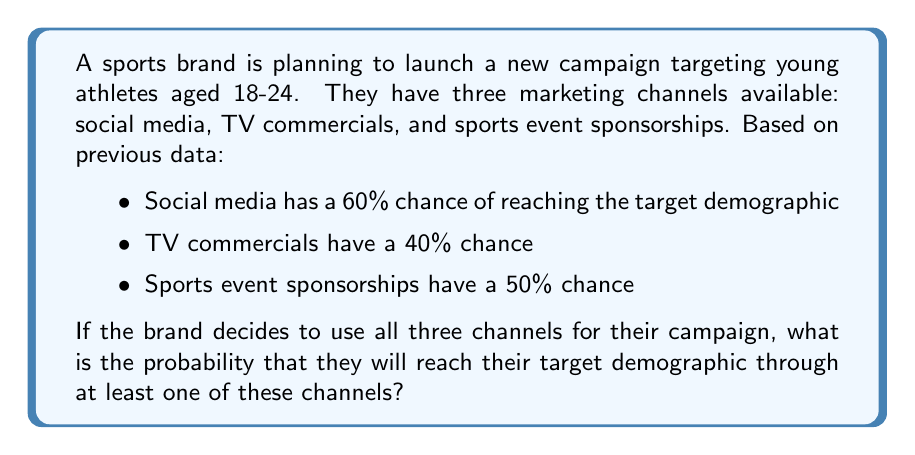Provide a solution to this math problem. To solve this problem, we need to use the concept of probability of the union of events. Instead of calculating the probability of reaching the target demographic through at least one channel, it's easier to calculate the probability of not reaching them through any channel and then subtract this from 1.

Let's break it down step-by-step:

1. Probability of not reaching through social media: $1 - 0.60 = 0.40$
2. Probability of not reaching through TV commercials: $1 - 0.40 = 0.60$
3. Probability of not reaching through sports event sponsorships: $1 - 0.50 = 0.50$

4. Probability of not reaching through any channel:
   $0.40 \times 0.60 \times 0.50 = 0.12$

5. Therefore, the probability of reaching through at least one channel:
   $1 - 0.12 = 0.88$

We can also express this using the complement rule:

$$P(\text{at least one}) = 1 - P(\text{none})$$
$$= 1 - [(1-0.60) \times (1-0.40) \times (1-0.50)]$$
$$= 1 - (0.40 \times 0.60 \times 0.50)$$
$$= 1 - 0.12 = 0.88$$

Thus, there is an 88% chance of reaching the target demographic through at least one of these channels.
Answer: 0.88 or 88% 